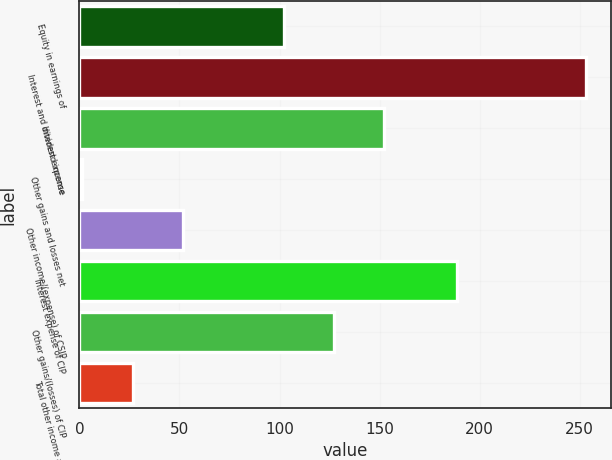Convert chart. <chart><loc_0><loc_0><loc_500><loc_500><bar_chart><fcel>Equity in earnings of<fcel>Interest and dividend income<fcel>Interest expense<fcel>Other gains and losses net<fcel>Other income/(expense) of CSIP<fcel>Interest expense of CIP<fcel>Other gains/(losses) of CIP<fcel>Total other income and<nl><fcel>102.1<fcel>253<fcel>152.4<fcel>1.5<fcel>51.8<fcel>188.9<fcel>127.25<fcel>26.65<nl></chart> 